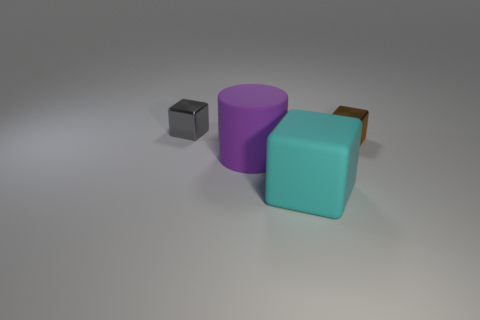Add 2 small shiny things. How many objects exist? 6 Subtract all cylinders. How many objects are left? 3 Subtract all gray objects. Subtract all green matte spheres. How many objects are left? 3 Add 2 cylinders. How many cylinders are left? 3 Add 3 green things. How many green things exist? 3 Subtract 0 blue cylinders. How many objects are left? 4 